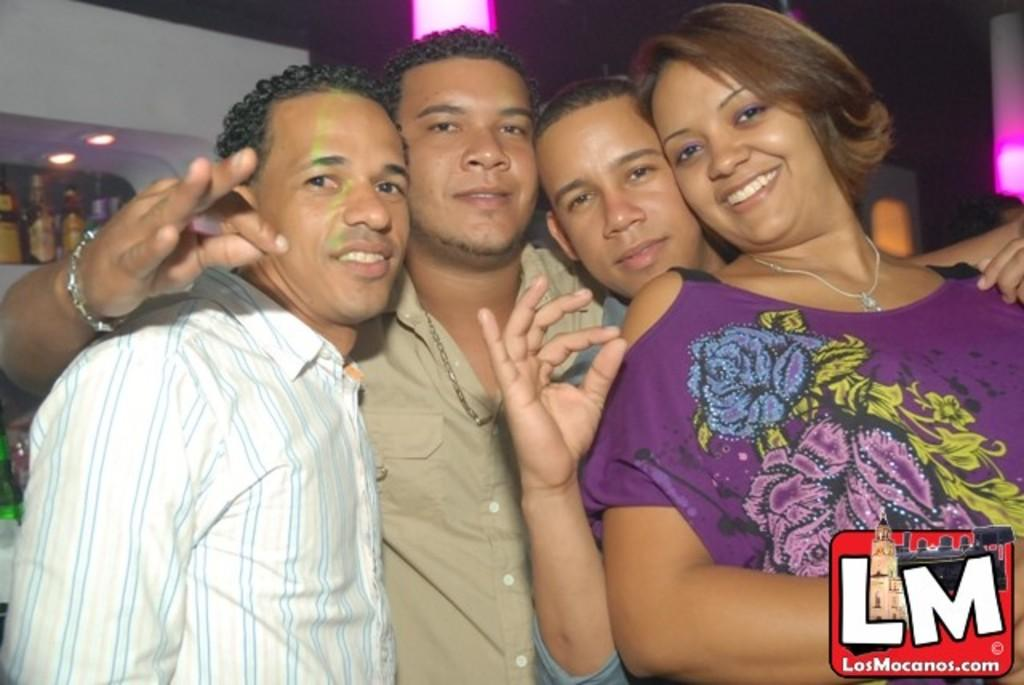Who or what is present in the image? There are people in the image. What objects can be seen alongside the people? There are bottles in the image. Is there any text visible in the image? Yes, there is written text at the bottom of the image. What is the governor's opinion on the club in the image? There is no mention of a club or a governor in the image, so it is not possible to determine their opinion. 